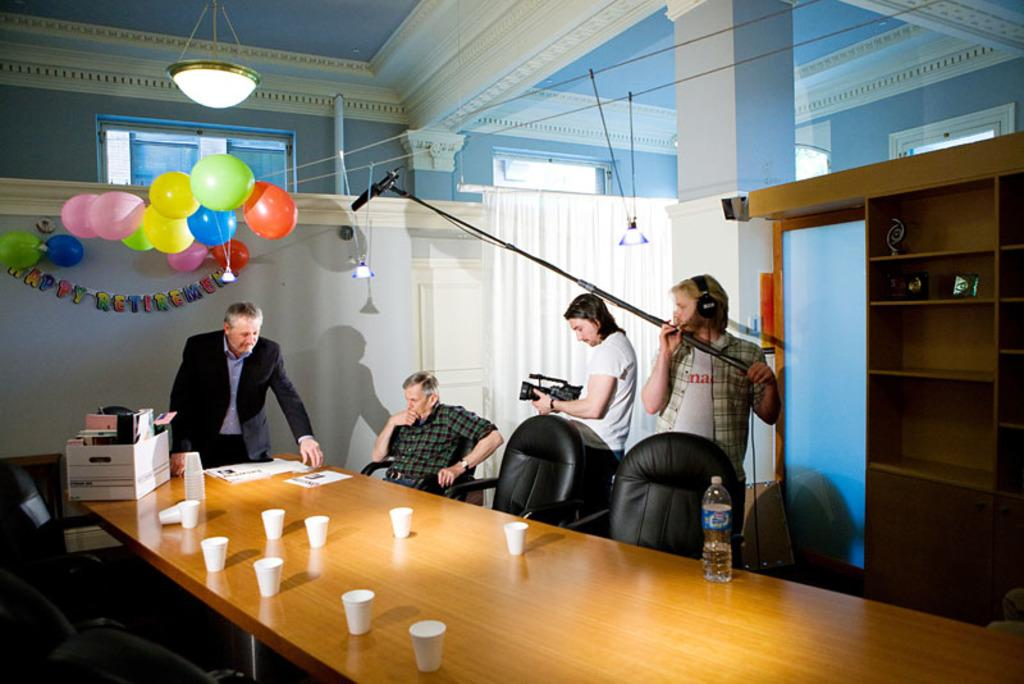What can be seen on the wall in the image? There are balloons in the image. What type of light source is visible in the image? There is a light in the image. What is used for amplifying sound in the image? There is a mic in the image. How many people are present in the image? There are people in the image. What is on the table in the image? There are glasses, a paper, and a box on the table. Can you tell me how many wounds are visible on the people in the image? There is no mention of any wounds on the people in the image; they appear to be uninjured. What type of verse can be heard being recited by the people in the image? There is no indication of any recitation or verse in the image; the people's actions are not described. 